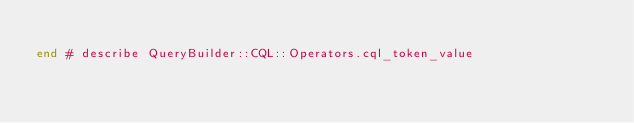Convert code to text. <code><loc_0><loc_0><loc_500><loc_500><_Ruby_>
end # describe QueryBuilder::CQL::Operators.cql_token_value
</code> 